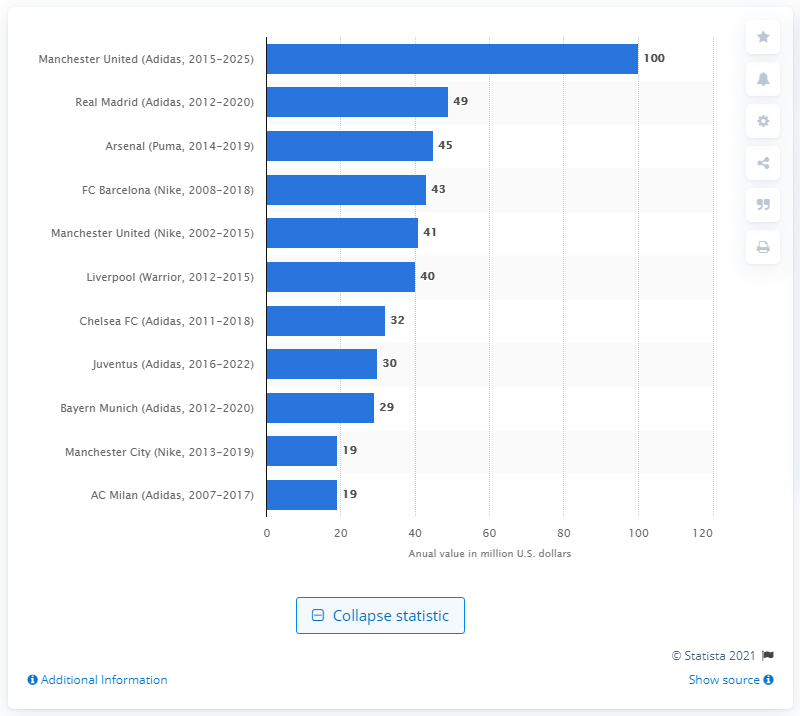Specify some key components in this picture. Manchester United has secured a significant annual sponsorship deal with Adidas, worth 100... 